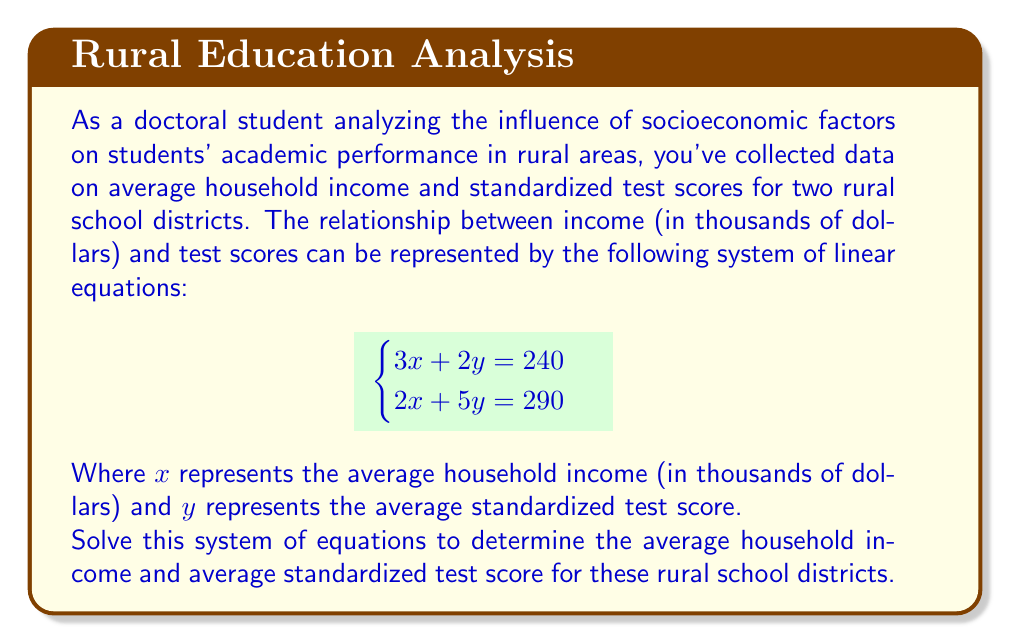Can you answer this question? To solve this system of linear equations, we'll use the elimination method:

1) First, multiply the first equation by 5 and the second equation by -2:

   $$\begin{aligned}
   5(3x + 2y = 240) &\rightarrow 15x + 10y = 1200 \\
   -2(2x + 5y = 290) &\rightarrow -4x - 10y = -580
   \end{aligned}$$

2) Add these equations to eliminate y:

   $$\begin{aligned}
   15x + 10y &= 1200 \\
   -4x - 10y &= -580 \\
   \hline
   11x &= 620
   \end{aligned}$$

3) Solve for x:

   $$x = \frac{620}{11} \approx 56.36$$

4) Substitute this value of x into one of the original equations, say the first one:

   $$\begin{aligned}
   3(56.36) + 2y &= 240 \\
   169.08 + 2y &= 240 \\
   2y &= 70.92 \\
   y &= 35.46
   \end{aligned}$$

5) Round the results to two decimal places:

   Average household income: $x \approx 56.36$ thousand dollars, or $56,360
   Average standardized test score: $y \approx 35.46$
Answer: The average household income is approximately $56,360, and the average standardized test score is approximately 35.46. 